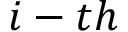<formula> <loc_0><loc_0><loc_500><loc_500>i - t h</formula> 